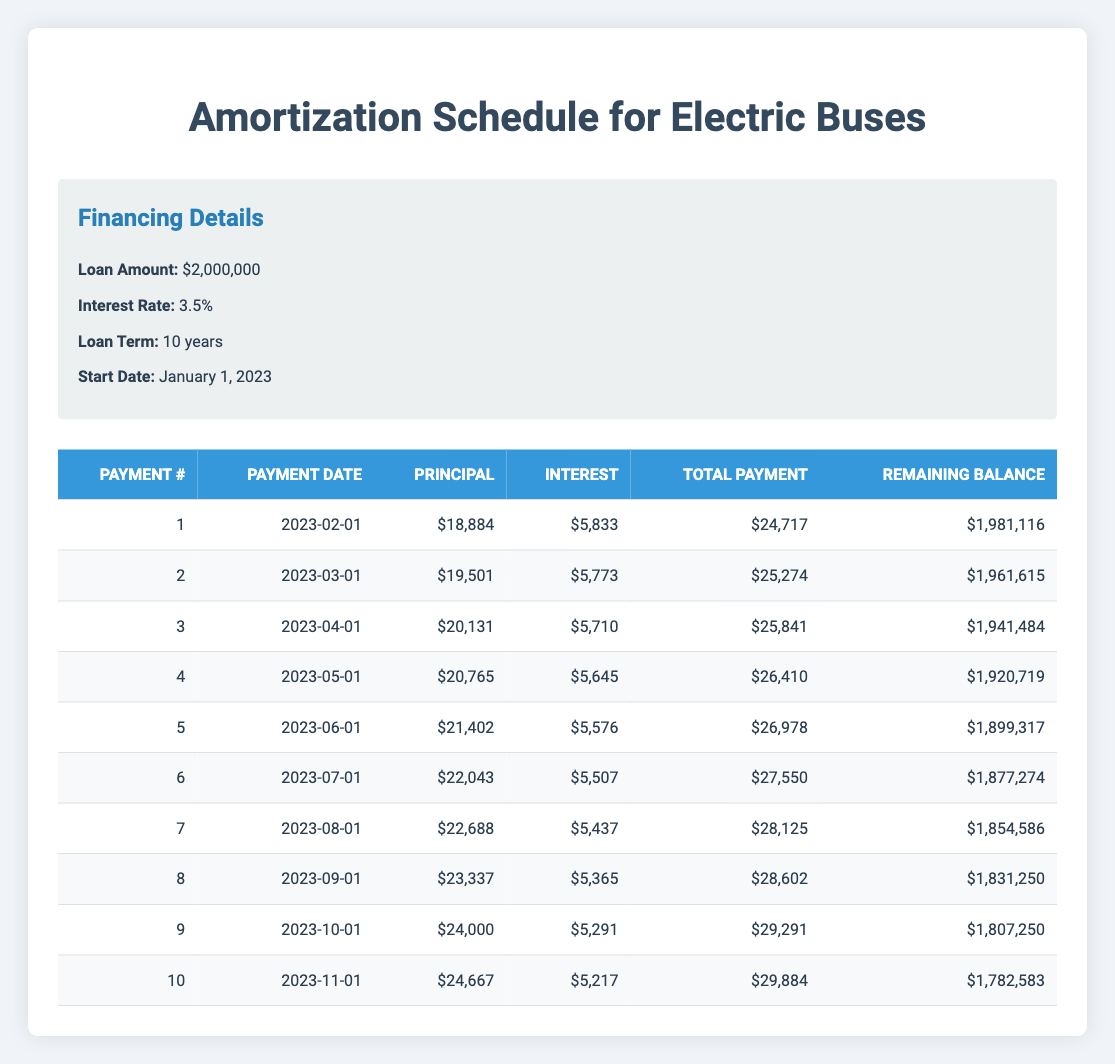What is the loan amount for the Electric Buses? The table shows the financing details at the top, where it states the loan amount is listed as 2,000,000.
Answer: 2,000,000 What is the total payment made in the third month? In the table, the third-month payment is recorded under total payment as 25,841, which is explicitly shown in that row.
Answer: 25,841 What is the remaining balance after the fifth payment? Looking at the fifth payment's row in the table, the remaining balance is shown to be 1,899,317, found directly in that specific row.
Answer: 1,899,317 Is the interest payment for the first month higher than the second month? By checking the first month's interest payment of 5,833 and the second of 5,773 in the respective rows, we see that 5,833 is greater than 5,773, confirming the statement is true.
Answer: Yes What is the total principal payment made from the first five payments combined? To find the combined principal payments, we add the principal payments for the first five months: 18,884 + 19,501 + 20,131 + 20,765 + 21,402 = 100,683.
Answer: 100,683 How much lower is the total payment of the tenth month compared to the total payment of the first month? The total payment for the tenth month is 29,884 and for the first month is 24,717. We calculate the difference: 29,884 - 24,717 = 5,167, indicating that the tenth month's payment is 5,167 higher.
Answer: 5,167 higher What is the average principal payment made during the first half of the loan term (first five payments)? To find the average, we first sum the principal payments for the first five payments: 18,884 + 19,501 + 20,131 + 20,765 + 21,402 = 100,683. Then, we divide by 5: 100,683 / 5 = 20,136.6, yielding an average.
Answer: 20,136.6 Is the interest payment in the fourth month less than 5,700? The interest payment for the fourth month is 5,645, which is indeed less than 5,700, confirming that the statement holds true.
Answer: Yes How much did the remaining balance decrease from the first month to the second month? The remaining balance after the first payment is 1,981,116 and after the second payment is 1,961,615. The decrease is calculated as 1,981,116 - 1,961,615 = 19,501.
Answer: 19,501 